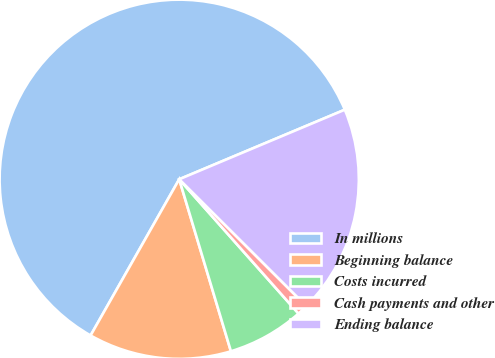Convert chart to OTSL. <chart><loc_0><loc_0><loc_500><loc_500><pie_chart><fcel>In millions<fcel>Beginning balance<fcel>Costs incurred<fcel>Cash payments and other<fcel>Ending balance<nl><fcel>60.45%<fcel>12.86%<fcel>6.91%<fcel>0.96%<fcel>18.81%<nl></chart> 